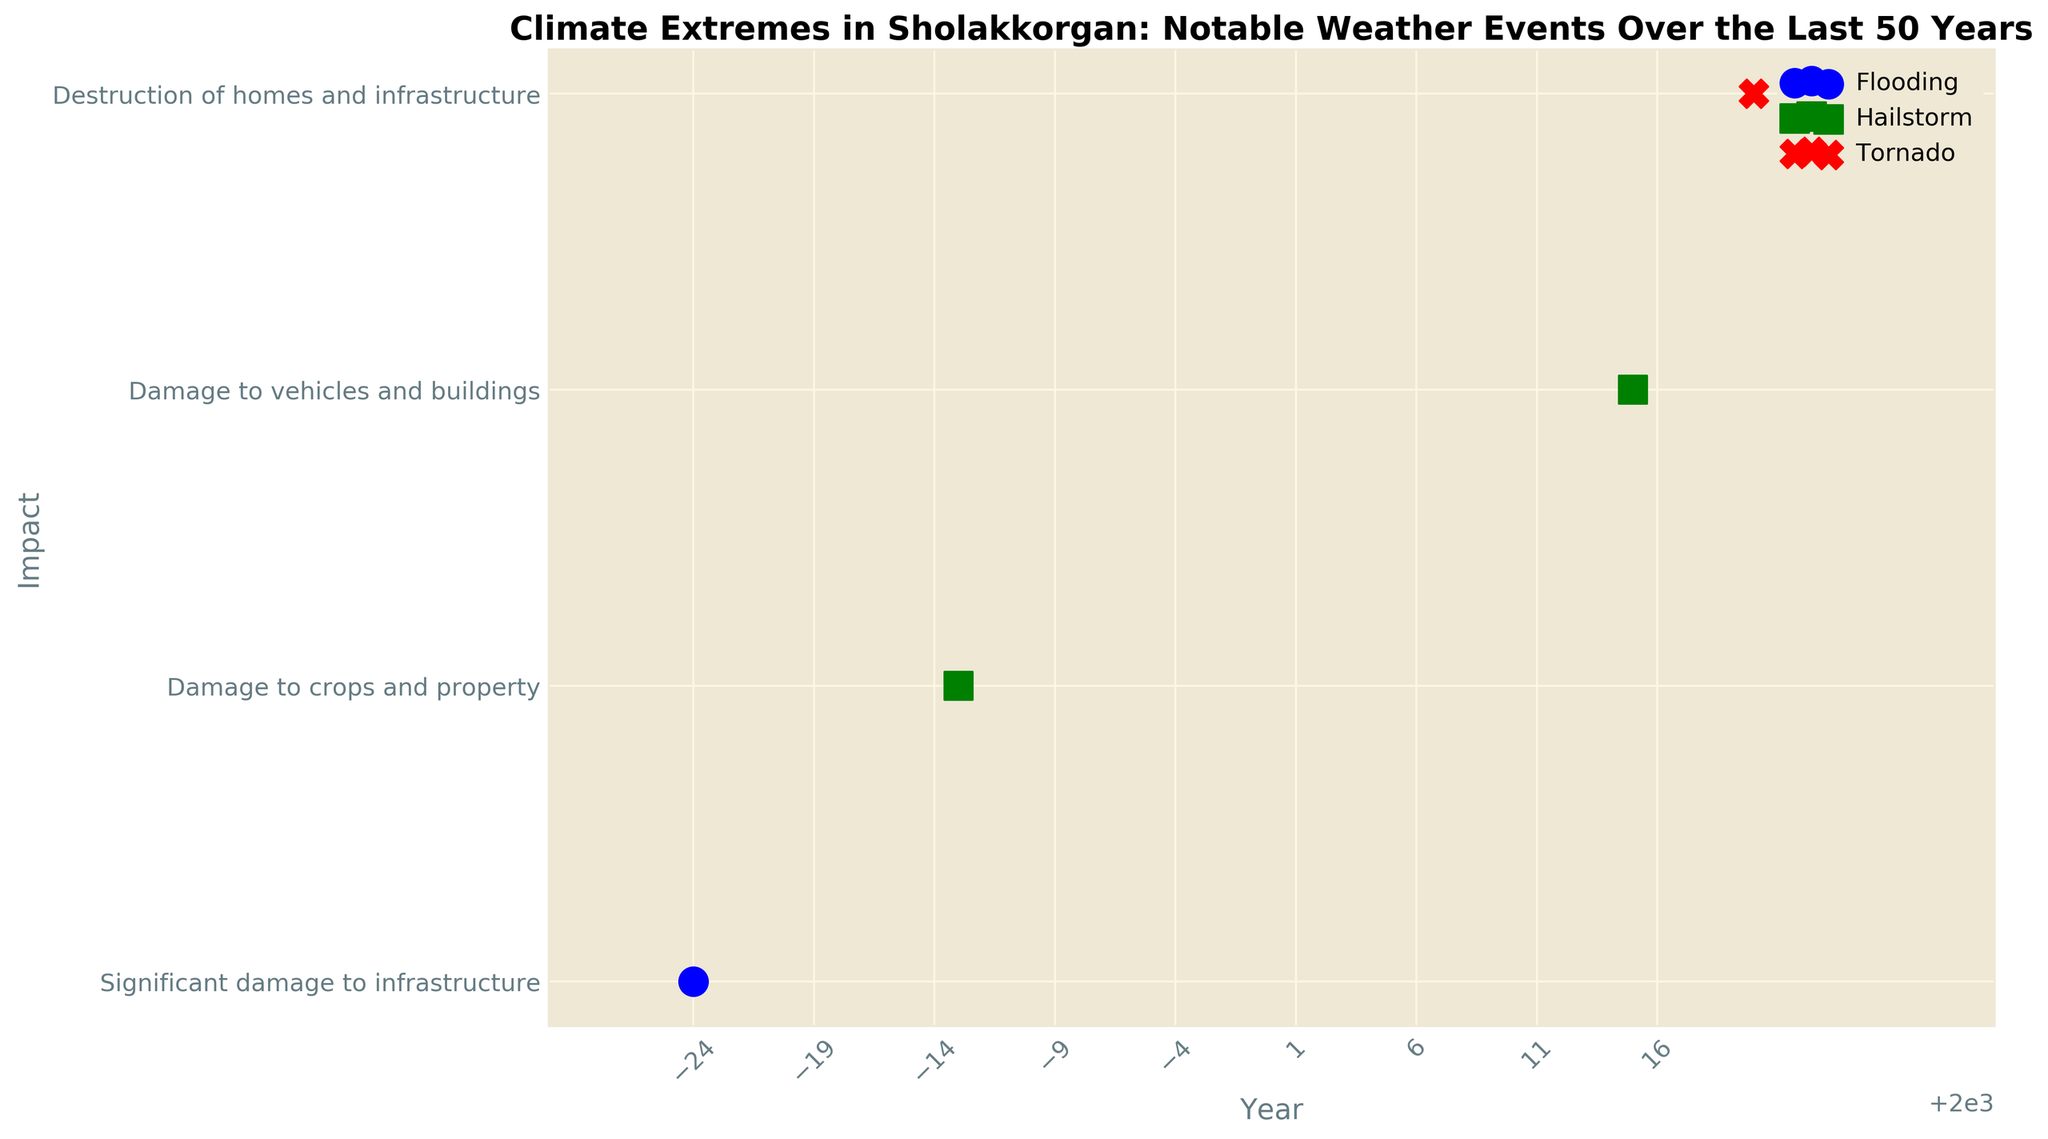What's the most extreme weather event in terms of severity in the plot? One of the events is marked with an 'X' which corresponds to an extreme severity event. This event is a Tornado in 2020
Answer: Tornado in 2020 Which type of weather event is represented with the color green? The legend indicates that each event type has a distinct color. Green corresponds to Precipitation events, so Hailstorms in 1987 and 2015 are depicted in green.
Answer: Hailstorm Which year had the most severe rainfall event? Referring to the figure, there is a severe event marked with an 'o' (circle) in blue, which represents Rainfall. The year associated with this event is 1976.
Answer: 1976 How many years are represented on the plot? The plot displays events from the years 1976, 1987, 2015, and 2020. Counting these unique years gives us four distinct points.
Answer: 4 How does the severity of the hailstorm in 1987 compare to the hailstorm in 2015? Both hailstorms have the same marker ('s' or square), indicating that they are of moderate severity. Therefore, the severity of both hailstorms is equivalent.
Answer: Equivalent Which event caused destruction of homes and infrastructure, and in which year did it occur? The description of impacts for each event is listed on the plot. The event noted for the "destruction of homes and infrastructure" is the Tornado in 2020.
Answer: Tornado in 2020 What are the different colors used to represent the event types, and which event types do they correspond to? By examining the plot legend, we can see that the colors used are blue for Rainfall, green for Precipitation, and red for Wind.
Answer: Blue for Rainfall, Green for Precipitation, Red for Wind Count the number of precipitation events indicated on the plot. On the plot, two green-colored markers are visible, which represent precipitation events. Therefore, there are two precipitation events.
Answer: 2 